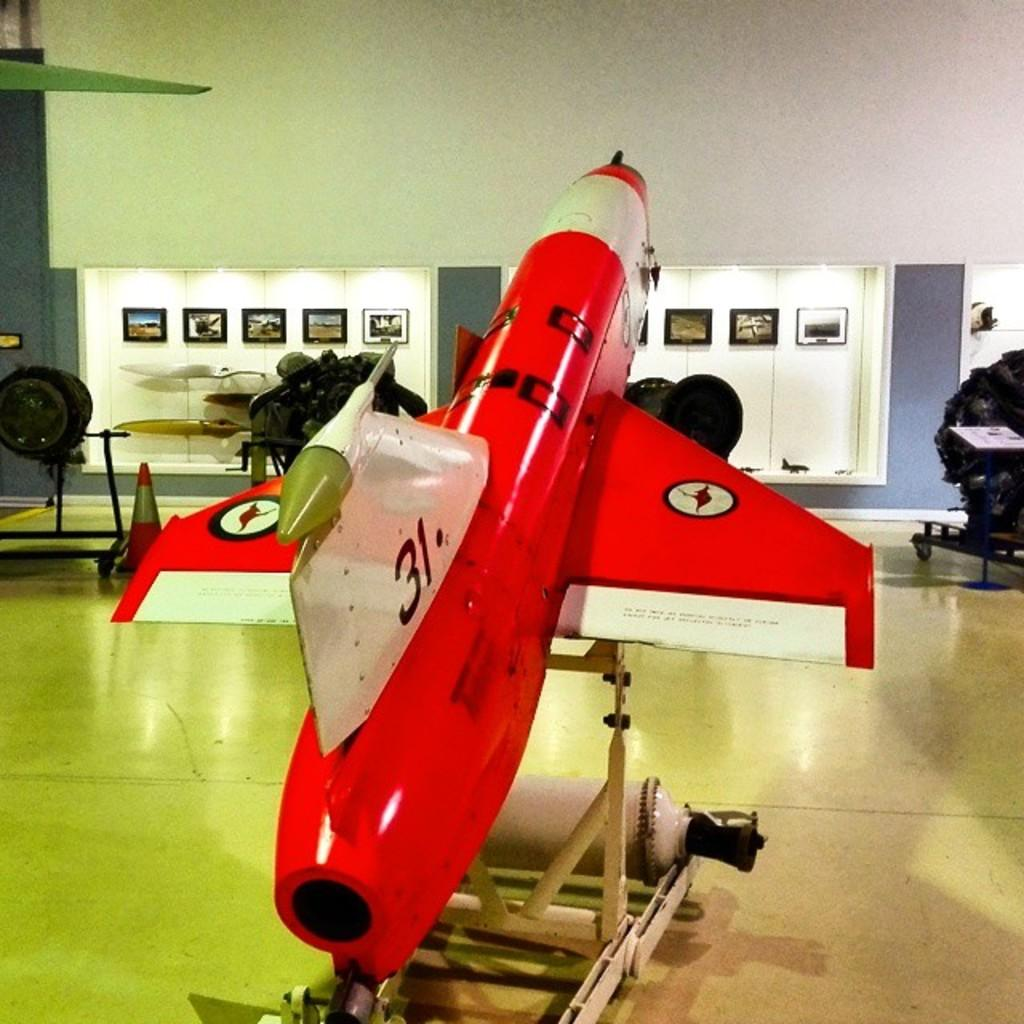What is the main subject of the picture? The main subject of the picture is an airplane. What other objects can be seen in the picture? There is a traffic cone and a stand in the picture. What is on the floor in the picture? There are objects on the floor in the picture. What can be seen in the background of the picture? There are frames and walls in the background of the picture. What type of art can be seen on the walls in the image? There is no art visible on the walls in the image; only frames are present. What color is the ink used to write on the traffic cone in the image? There is no ink or writing on the traffic cone in the image. 